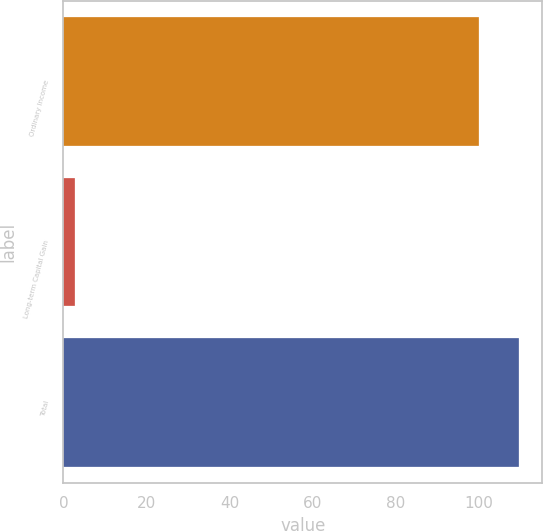Convert chart to OTSL. <chart><loc_0><loc_0><loc_500><loc_500><bar_chart><fcel>Ordinary Income<fcel>Long-term Capital Gain<fcel>Total<nl><fcel>100<fcel>2.78<fcel>109.72<nl></chart> 